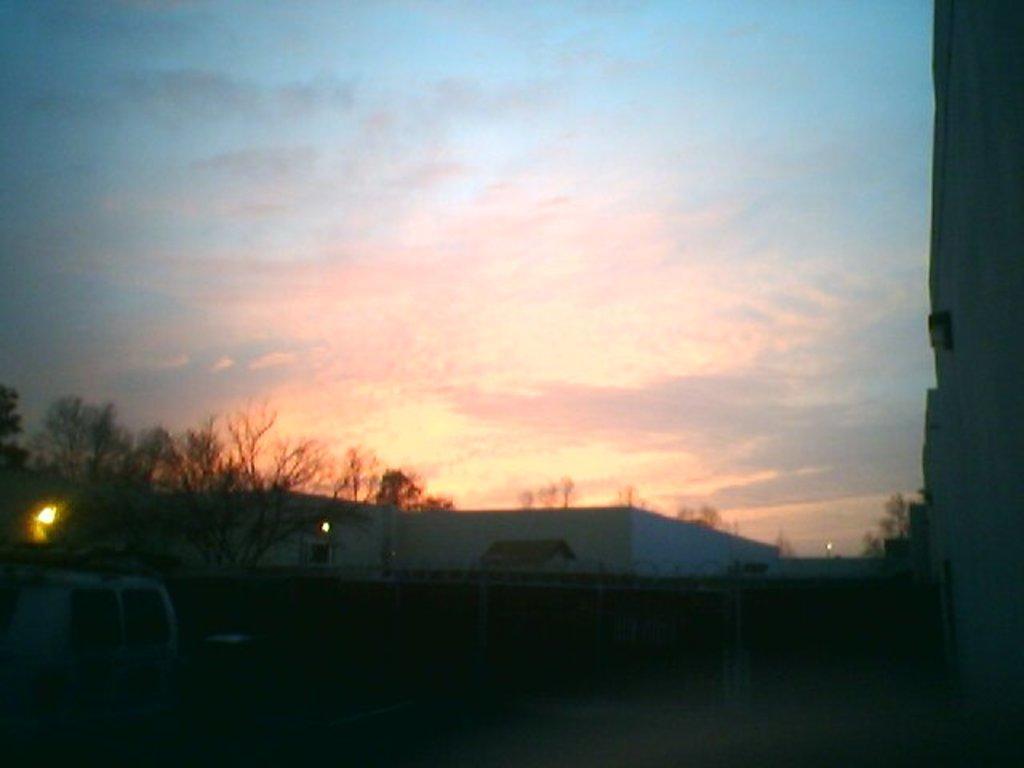Can you describe this image briefly? In this picture we can see a vehicle, lights, trees, buildings with windows and in the background we can see the sky with clouds. 